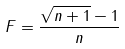Convert formula to latex. <formula><loc_0><loc_0><loc_500><loc_500>F = \frac { \sqrt { n + 1 } - 1 } { n }</formula> 